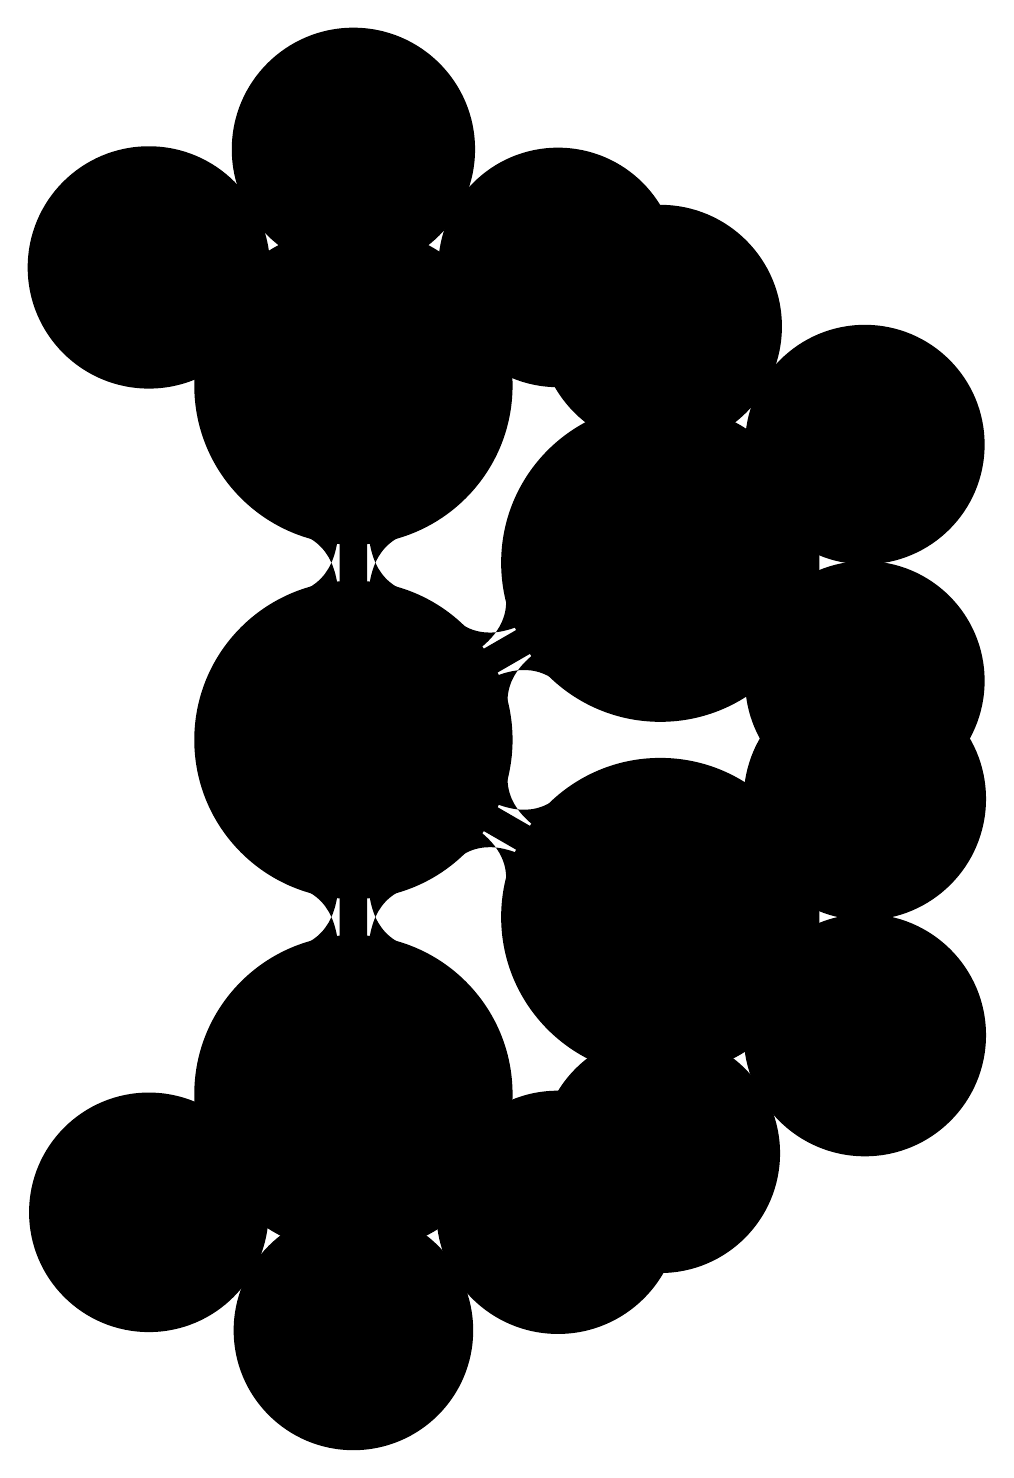What are the three categories of memorable experiences with Tony? The diagram outlines four main categories branching from the central node. The first three categories listed are "Cycling Adventures," "Memorable Moments," and "Special Events."
Answer: Cycling Adventures, Memorable Moments, Special Events Which cycling event is listed under Special Events? In the diagram, the "Special Events" category includes three events. Among them, one is specifically "Tour de Cure."
Answer: Tour de Cure What is the longest ride mentioned in Memorable Moments? In the "Memorable Moments" section, the longest ride specifically stated is the "200-mile charity ride."
Answer: 200-mile charity ride How many favorite spots are mentioned in the diagram? The "Favorite Spots" category includes three unique locations, which are outlined in the diagram. Counting them gives the total number as three.
Answer: 3 Name one cycling adventure from the diagram. There are three options listed under "Cycling Adventures." One notable cycling adventure mentioned is the "Pacific Coast Highway."
Answer: Pacific Coast Highway Which scenic route is mentioned as the challenging hill in Favorite Spots? Under the "Favorite Spots" section, the "Most Challenging Hill" is specifically noted as "Alpe d'Huez replica in California," highlighting its challenge.
Answer: Alpe d'Huez replica in California What unexpected encounter is mentioned in Memorable Moments? Within the "Memorable Moments" category, one specific unexpected encounter is highlighted as "Bear sighting in Yellowstone."
Answer: Bear sighting in Yellowstone Which cycling adventure is located in the Blue Ridge Mountains? In the "Cycling Adventures" section, it is clearly stated that one adventure is tied to the "Blue Ridge Mountains."
Answer: Blue Ridge Mountains List the two scenic trails mentioned under Cycling Adventures. The "Cycling Adventures" category contains three trails, out of which two that can be noted are "Blue Ridge Mountains" and "Pacific Coast Highway."
Answer: Blue Ridge Mountains, Pacific Coast Highway 